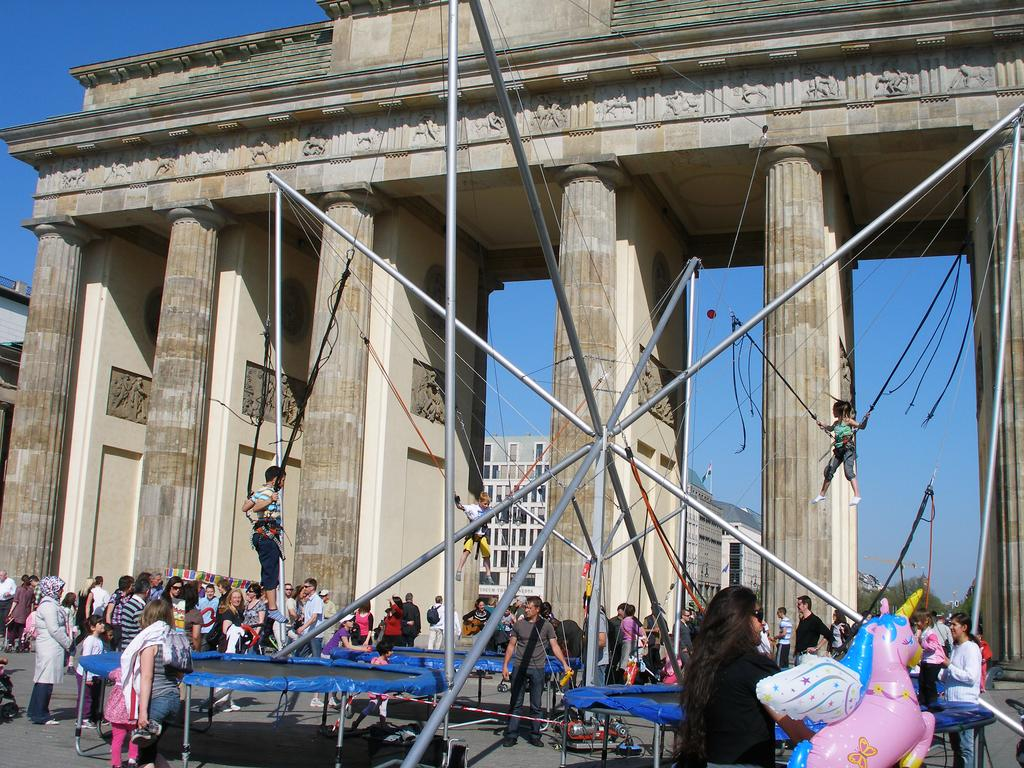What type of structure is featured in the image? There is a historical construction in the image. Are there any people present in the image? Yes, there are people standing near the historical construction. What else can be seen in the background of the image? There is a building visible behind the historical construction. What is visible in the sky in the image? The sky is visible in the image. How many stars can be seen on the sand in the image? There are no stars or sand present in the image; it features a historical construction, people, and a building in the background. 